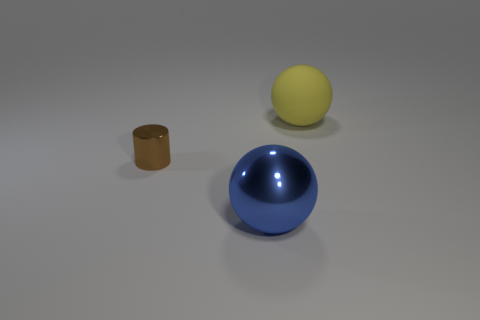Is there anything else that has the same size as the blue shiny object?
Provide a succinct answer. Yes. What material is the tiny cylinder that is behind the thing in front of the cylinder?
Offer a terse response. Metal. There is a thing that is both to the right of the tiny brown cylinder and behind the big blue sphere; what shape is it?
Your response must be concise. Sphere. What is the size of the other object that is the same shape as the blue object?
Keep it short and to the point. Large. Is the number of small metallic things to the right of the big metal object less than the number of big yellow balls?
Provide a short and direct response. Yes. There is a metal thing that is to the right of the brown shiny cylinder; how big is it?
Ensure brevity in your answer.  Large. What is the color of the large shiny thing that is the same shape as the big matte object?
Ensure brevity in your answer.  Blue. Is there any other thing that has the same shape as the tiny metallic thing?
Your answer should be very brief. No. There is a sphere in front of the thing that is behind the brown cylinder; are there any big yellow rubber objects on the right side of it?
Keep it short and to the point. Yes. What number of big blue spheres are the same material as the brown object?
Your response must be concise. 1. 